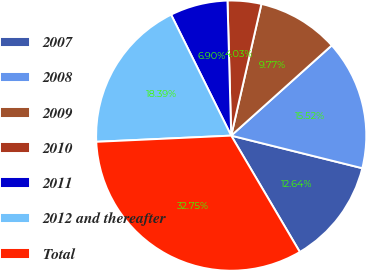Convert chart to OTSL. <chart><loc_0><loc_0><loc_500><loc_500><pie_chart><fcel>2007<fcel>2008<fcel>2009<fcel>2010<fcel>2011<fcel>2012 and thereafter<fcel>Total<nl><fcel>12.64%<fcel>15.52%<fcel>9.77%<fcel>4.03%<fcel>6.9%<fcel>18.39%<fcel>32.75%<nl></chart> 